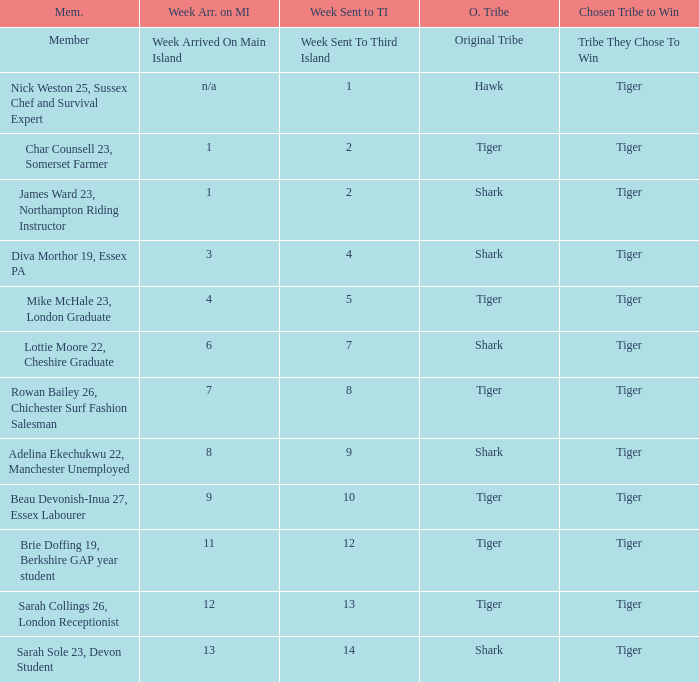What week did the member who's original tribe was shark and who was sent to the third island on week 14 arrive on the main island? 13.0. 